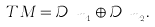<formula> <loc_0><loc_0><loc_500><loc_500>T M = \mathcal { D } _ { \ m _ { 1 } } \oplus \mathcal { D } _ { \ m _ { 2 } } .</formula> 